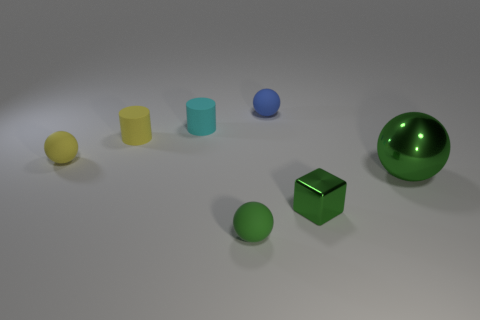What can this array of objects tell us about lighting and perspective? The array of objects offers clues about the lighting setup and perspective. The shadows of the objects suggest a single light source from above, at a slight angle. As the shadows are soft-edged, the light source is likely diffused. The size variation and positioning of the objects give a sense of depth, creating a three-dimensional perspective. The objects are arranged from smaller to larger, enhancing the effect of perspective through forced depth. 